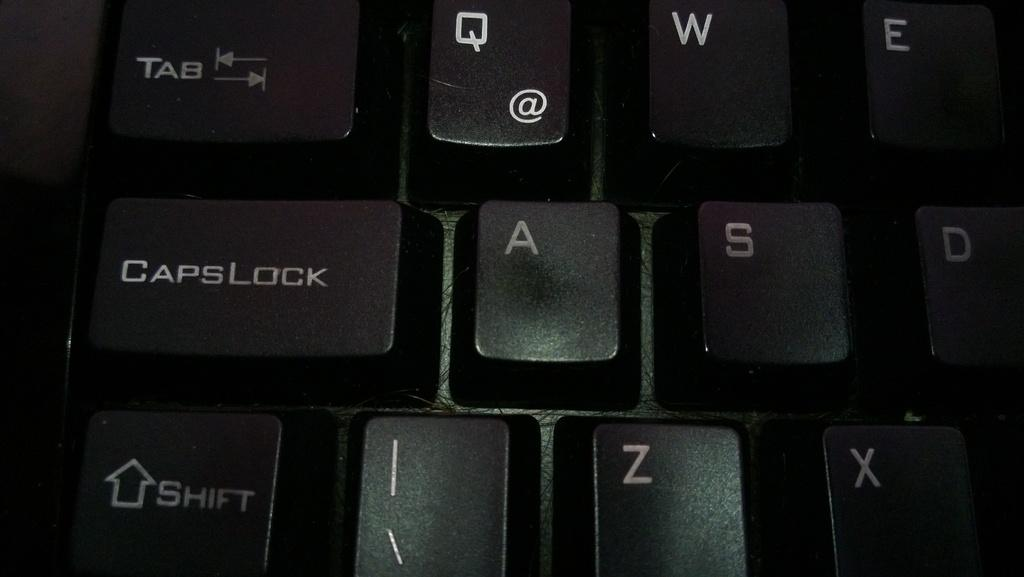Provide a one-sentence caption for the provided image. keyboard keys called 'tab, capslock, and shift' and a few letters. 